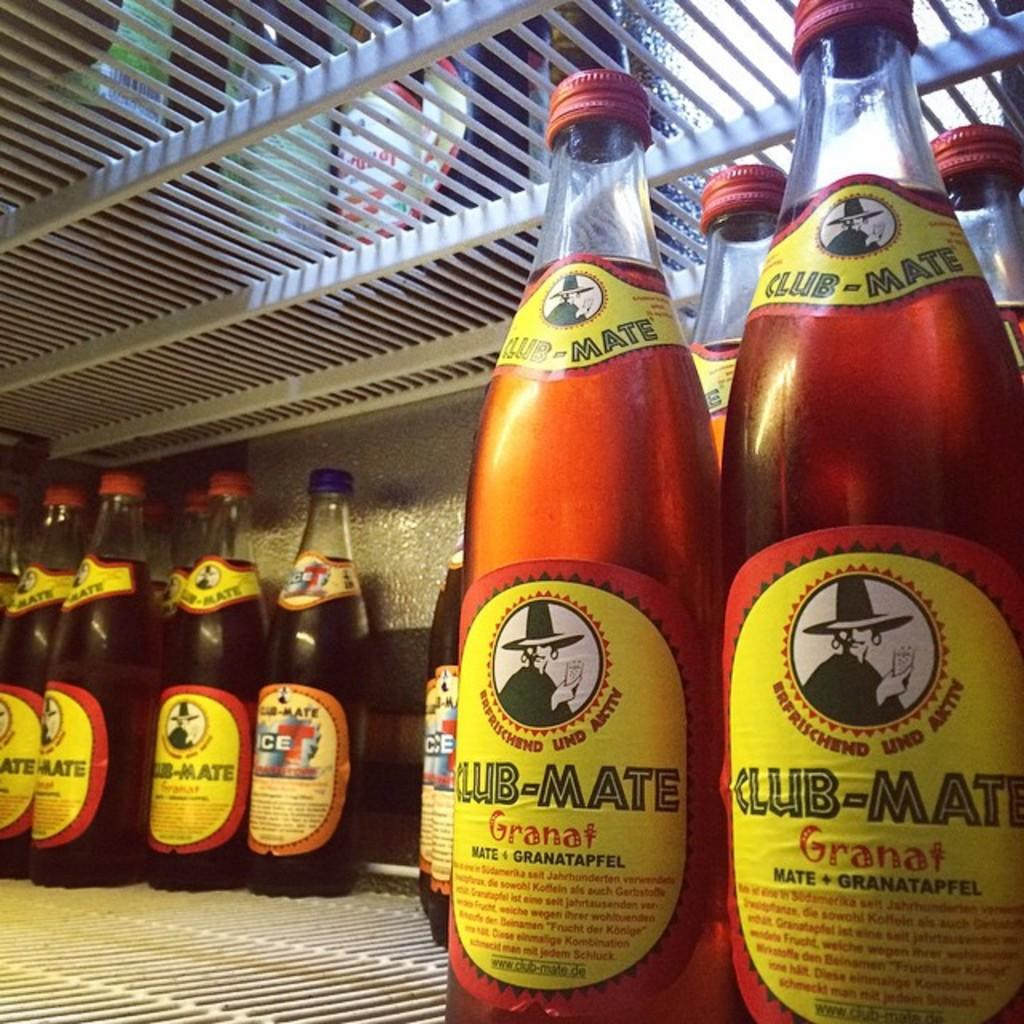<image>
Share a concise interpretation of the image provided. many red bottles of Club Mate Granat on a fridge shelf 